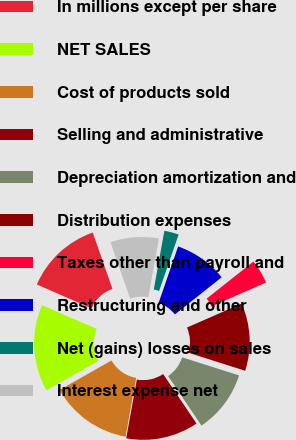Convert chart to OTSL. <chart><loc_0><loc_0><loc_500><loc_500><pie_chart><fcel>In millions except per share<fcel>NET SALES<fcel>Cost of products sold<fcel>Selling and administrative<fcel>Depreciation amortization and<fcel>Distribution expenses<fcel>Taxes other than payroll and<fcel>Restructuring and other<fcel>Net (gains) losses on sales<fcel>Interest expense net<nl><fcel>13.11%<fcel>14.75%<fcel>13.93%<fcel>12.29%<fcel>10.66%<fcel>11.48%<fcel>4.1%<fcel>9.02%<fcel>2.46%<fcel>8.2%<nl></chart> 